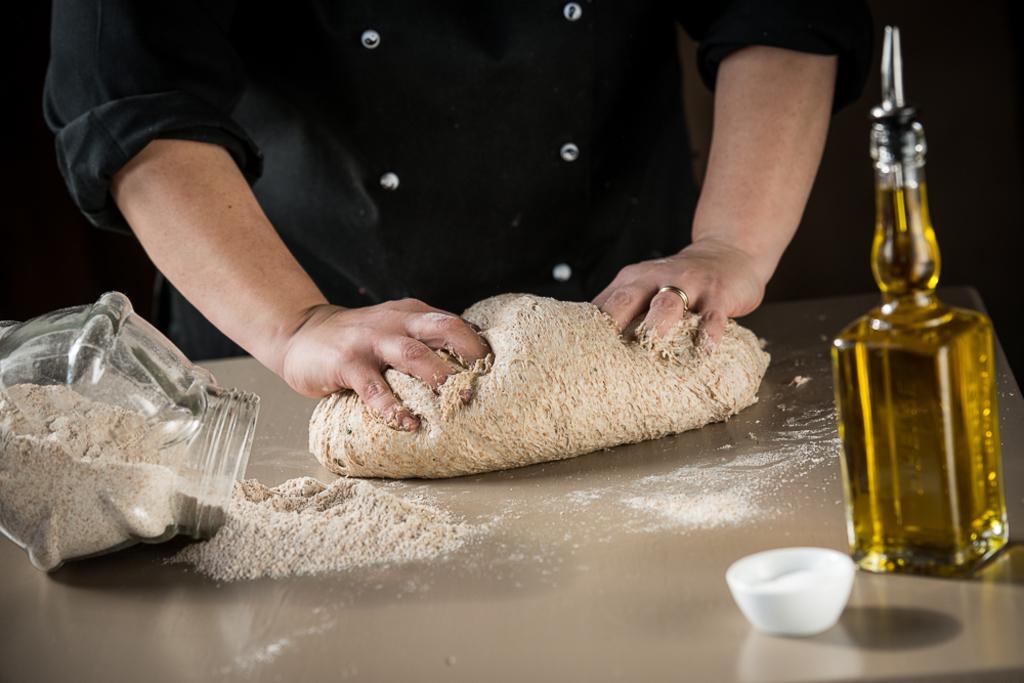Could you give a brief overview of what you see in this image? A person is mixing the flour with his hands beside of it there is a oil bottle and in the right it's a flour jar. 